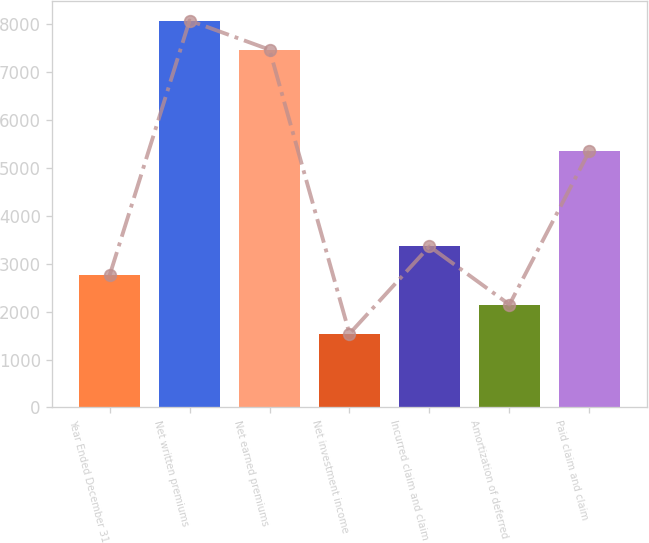<chart> <loc_0><loc_0><loc_500><loc_500><bar_chart><fcel>Year Ended December 31<fcel>Net written premiums<fcel>Net earned premiums<fcel>Net investment income<fcel>Incurred claim and claim<fcel>Amortization of deferred<fcel>Paid claim and claim<nl><fcel>2756.6<fcel>8078.8<fcel>7471<fcel>1541<fcel>3364.4<fcel>2148.8<fcel>5354.8<nl></chart> 